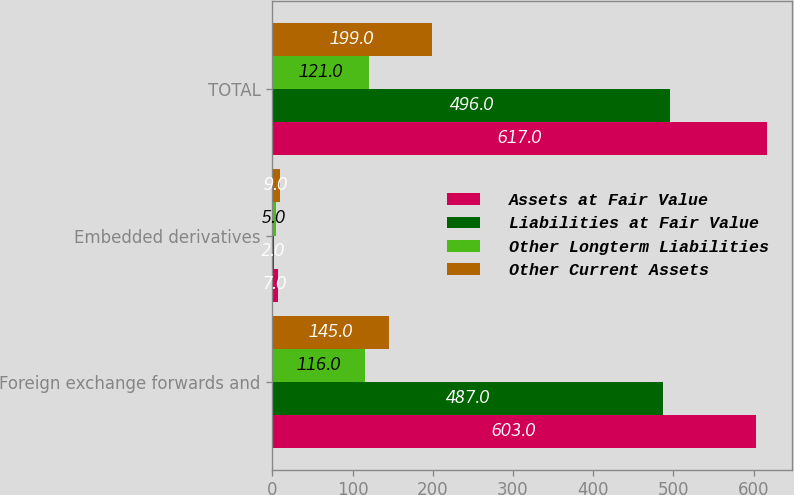Convert chart to OTSL. <chart><loc_0><loc_0><loc_500><loc_500><stacked_bar_chart><ecel><fcel>Foreign exchange forwards and<fcel>Embedded derivatives<fcel>TOTAL<nl><fcel>Assets at Fair Value<fcel>603<fcel>7<fcel>617<nl><fcel>Liabilities at Fair Value<fcel>487<fcel>2<fcel>496<nl><fcel>Other Longterm Liabilities<fcel>116<fcel>5<fcel>121<nl><fcel>Other Current Assets<fcel>145<fcel>9<fcel>199<nl></chart> 